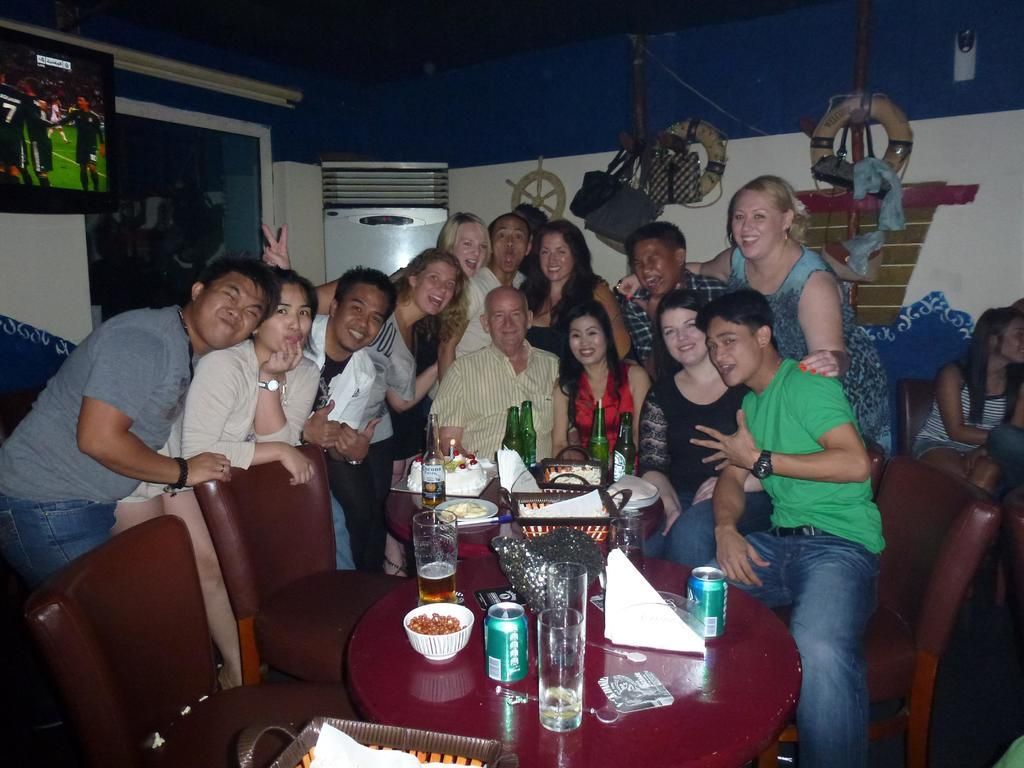How many people are in the group in the image? The number of people in the group cannot be determined from the provided facts. What are the people in the group doing? The persons in the group are sitting and posing for a photograph. What objects are in front of the group? There are bottles, food items, and a cake in front of the group. What type of hole can be seen in the image? There is no hole present in the image. Can you describe the prose written on the cake in the image? There is no prose or writing visible on the cake in the image. 